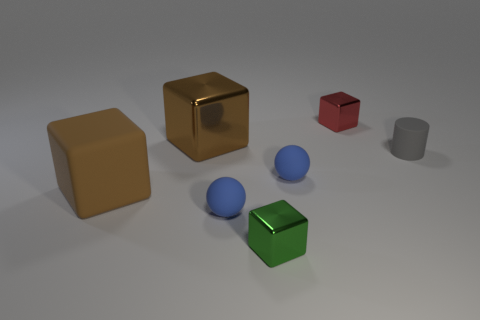The block that is the same material as the gray thing is what color?
Your answer should be very brief. Brown. What number of red things have the same material as the gray thing?
Offer a very short reply. 0. Does the blue rubber thing to the right of the green shiny cube have the same size as the large brown metal object?
Give a very brief answer. No. There is a thing that is the same size as the rubber block; what color is it?
Give a very brief answer. Brown. There is a tiny gray cylinder; how many gray cylinders are to the right of it?
Keep it short and to the point. 0. Is there a red shiny thing?
Provide a short and direct response. Yes. There is a blue object behind the blue sphere in front of the blue thing to the right of the tiny green object; what size is it?
Your answer should be very brief. Small. How many other things are the same size as the gray rubber cylinder?
Provide a succinct answer. 4. There is a metallic object that is in front of the brown metal object; what is its size?
Your answer should be compact. Small. Are there any other things that are the same color as the small cylinder?
Your answer should be very brief. No. 